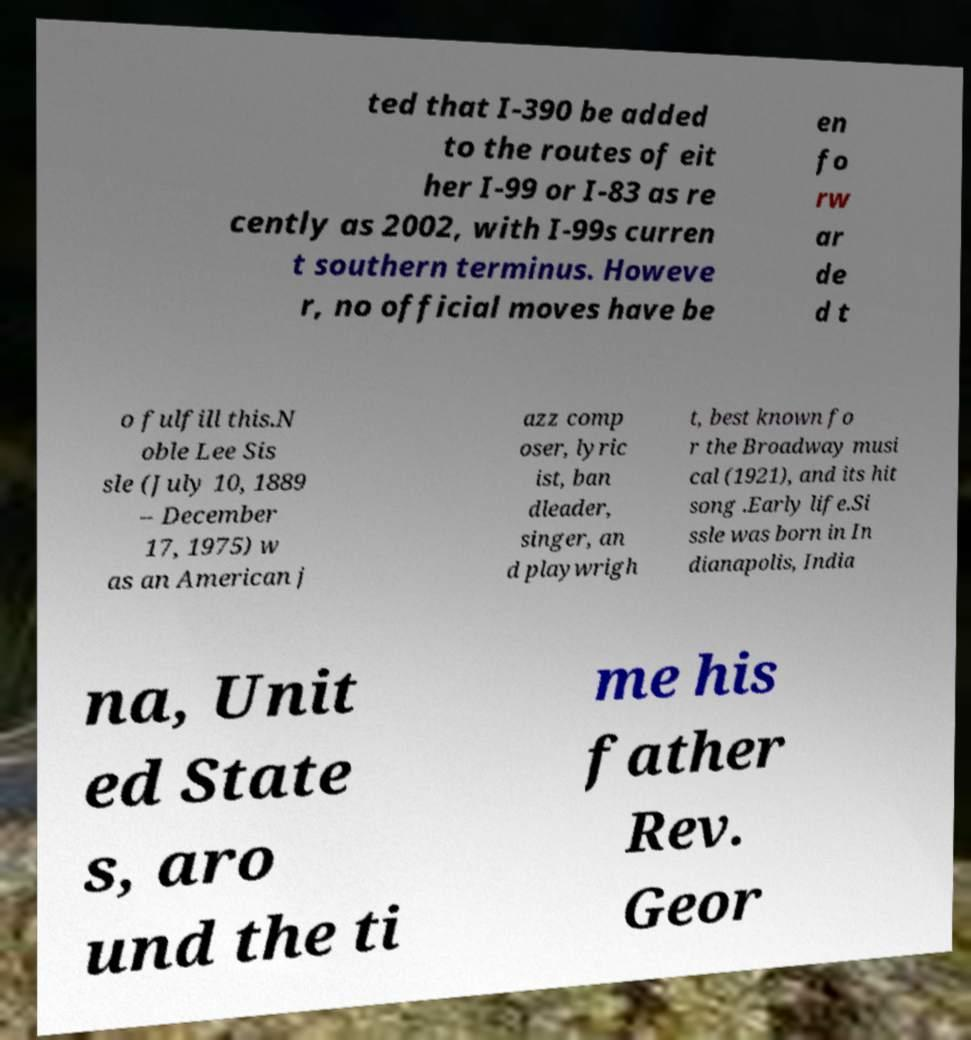For documentation purposes, I need the text within this image transcribed. Could you provide that? ted that I-390 be added to the routes of eit her I-99 or I-83 as re cently as 2002, with I-99s curren t southern terminus. Howeve r, no official moves have be en fo rw ar de d t o fulfill this.N oble Lee Sis sle (July 10, 1889 – December 17, 1975) w as an American j azz comp oser, lyric ist, ban dleader, singer, an d playwrigh t, best known fo r the Broadway musi cal (1921), and its hit song .Early life.Si ssle was born in In dianapolis, India na, Unit ed State s, aro und the ti me his father Rev. Geor 